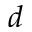Convert formula to latex. <formula><loc_0><loc_0><loc_500><loc_500>d</formula> 